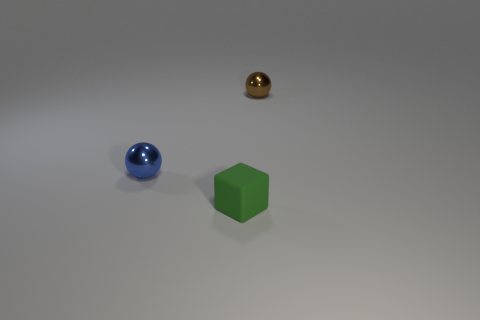Add 1 tiny brown objects. How many objects exist? 4 Subtract all spheres. How many objects are left? 1 Add 2 purple things. How many purple things exist? 2 Subtract 0 cyan balls. How many objects are left? 3 Subtract all cubes. Subtract all small rubber blocks. How many objects are left? 1 Add 2 green matte blocks. How many green matte blocks are left? 3 